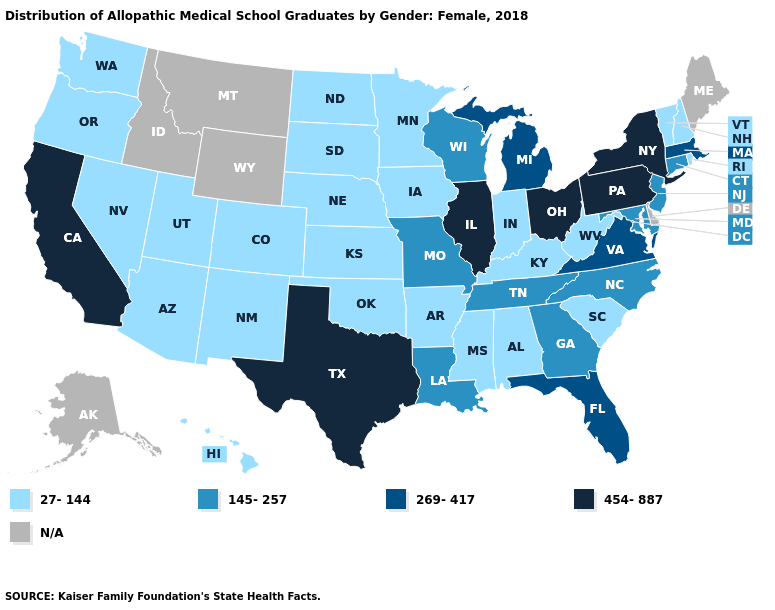What is the value of Arizona?
Concise answer only. 27-144. What is the value of Michigan?
Quick response, please. 269-417. What is the highest value in states that border Montana?
Short answer required. 27-144. Name the states that have a value in the range 27-144?
Quick response, please. Alabama, Arizona, Arkansas, Colorado, Hawaii, Indiana, Iowa, Kansas, Kentucky, Minnesota, Mississippi, Nebraska, Nevada, New Hampshire, New Mexico, North Dakota, Oklahoma, Oregon, Rhode Island, South Carolina, South Dakota, Utah, Vermont, Washington, West Virginia. Does California have the lowest value in the West?
Give a very brief answer. No. Name the states that have a value in the range N/A?
Short answer required. Alaska, Delaware, Idaho, Maine, Montana, Wyoming. What is the value of Florida?
Quick response, please. 269-417. What is the highest value in states that border West Virginia?
Short answer required. 454-887. How many symbols are there in the legend?
Concise answer only. 5. What is the lowest value in states that border Virginia?
Quick response, please. 27-144. What is the value of West Virginia?
Write a very short answer. 27-144. Name the states that have a value in the range 269-417?
Concise answer only. Florida, Massachusetts, Michigan, Virginia. Does the map have missing data?
Write a very short answer. Yes. Does Virginia have the highest value in the South?
Short answer required. No. 